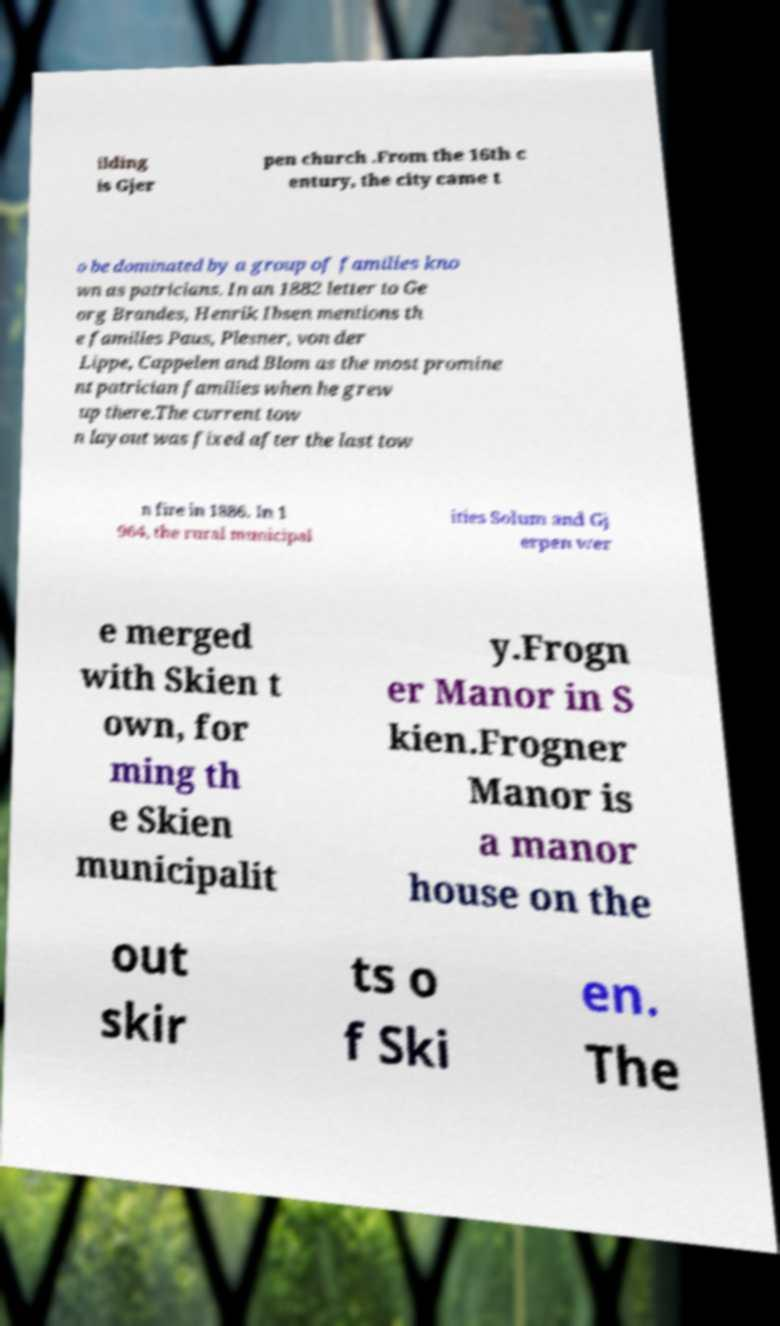Please identify and transcribe the text found in this image. ilding is Gjer pen church .From the 16th c entury, the city came t o be dominated by a group of families kno wn as patricians. In an 1882 letter to Ge org Brandes, Henrik Ibsen mentions th e families Paus, Plesner, von der Lippe, Cappelen and Blom as the most promine nt patrician families when he grew up there.The current tow n layout was fixed after the last tow n fire in 1886. In 1 964, the rural municipal ities Solum and Gj erpen wer e merged with Skien t own, for ming th e Skien municipalit y.Frogn er Manor in S kien.Frogner Manor is a manor house on the out skir ts o f Ski en. The 